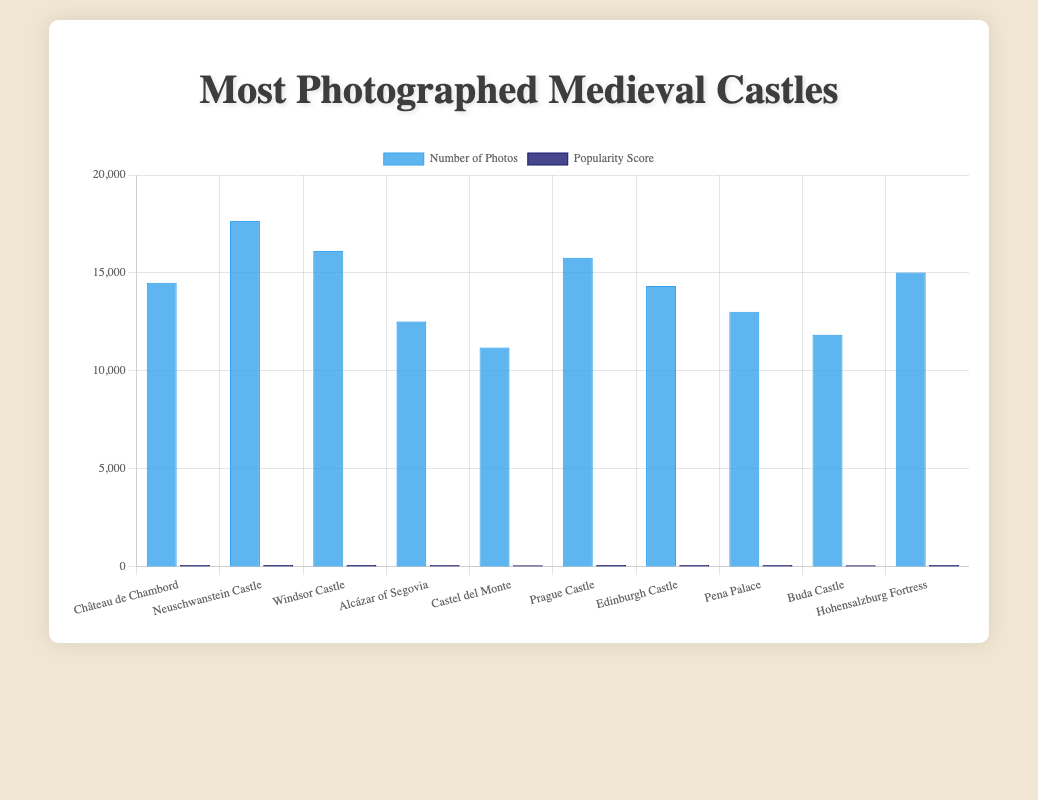Which castle has the highest number of photos? Neuschwanstein Castle in Germany has the highest number of photos. You can identify it by the bar representing this castle being the tallest among all the bars for photos.
Answer: Neuschwanstein Castle Which castle has the highest popularity score? Neuschwanstein Castle also has the highest popularity score. The bar for its popularity score is the tallest among all the popularity score bars.
Answer: Neuschwanstein Castle What is the difference in the number of photos between Neuschwanstein Castle and Château de Chambord? Neuschwanstein Castle has 17650 photos, and Château de Chambord has 14500. The difference is calculated as 17650 - 14500.
Answer: 3150 Which castle in the United Kingdom has more photos, Windsor Castle or Edinburgh Castle? Windsor Castle has 16120 photos while Edinburgh Castle has 14340 photos. Comparing these numbers, Windsor Castle has more photos.
Answer: Windsor Castle How many total photos are there for castles in France and Italy combined? Château de Chambord has 14500 photos, and Castel del Monte has 11200. Summing these gives 14500 + 11200.
Answer: 25700 Which country has the castle with the lowest popularity score? By comparing the heights of the bars for popularity scores, Italy's Castel del Monte has the lowest popularity score, which is 89.
Answer: Italy Between Alcázar of Segovia and Buda Castle, which has a higher popularity score? Alcázar of Segovia has a popularity score of 91, whereas Buda Castle has a score of 90. Alcázar of Segovia's bar for popularity score is taller.
Answer: Alcázar of Segovia What is the average number of photos for Hohensalzburg Fortress and Prague Castle? Hohensalzburg Fortress has 15030 photos and Prague Castle has 15780 photos. The average is (15030 + 15780) / 2.
Answer: 15405 How many castles have a popularity score greater than 95? Neuschwanstein Castle (98), Windsor Castle (97), and Prague Castle (96) have popularity scores greater than 95.
Answer: 3 Which castle's number of photos is closest to 15000? Hohensalzburg Fortress in Austria has 15030 photos, which is closest to 15000 when compared to other castles.
Answer: Hohensalzburg Fortress 